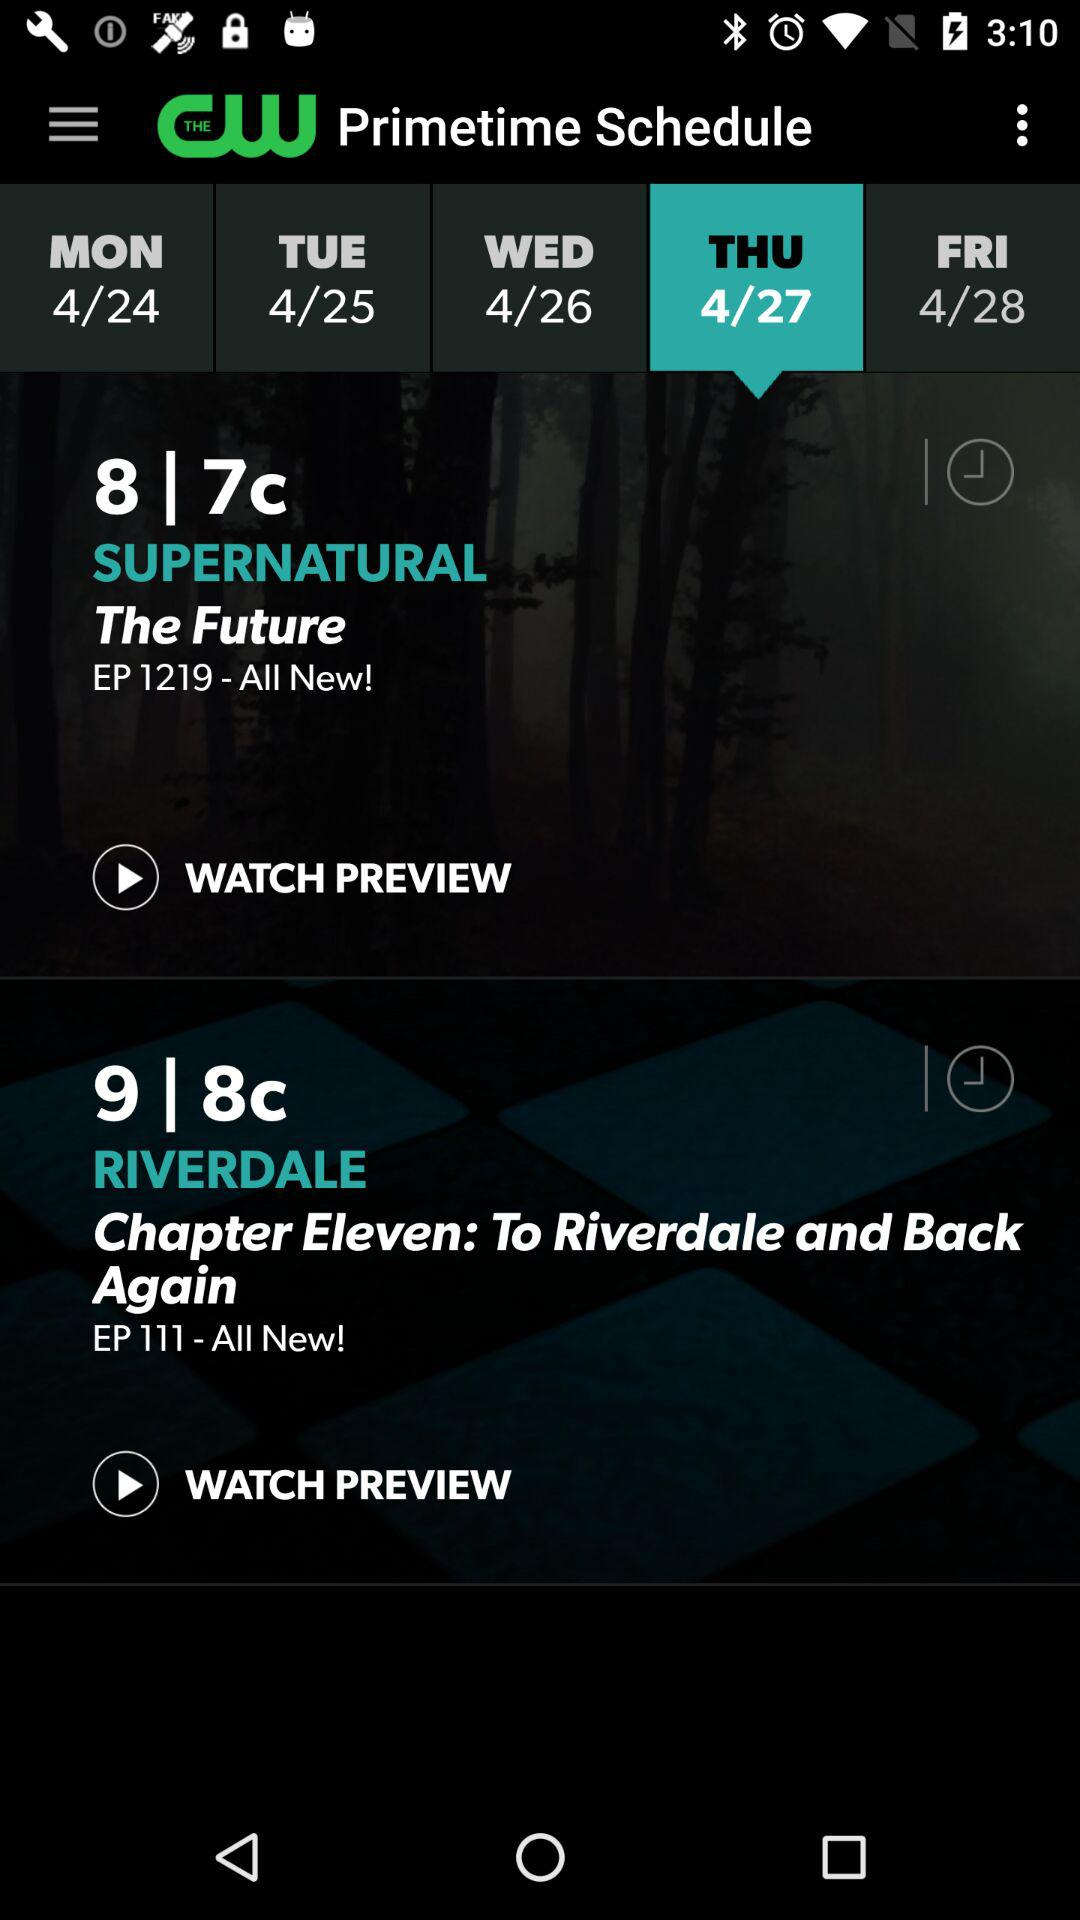How many days of the week are available to view?
Answer the question using a single word or phrase. 5 